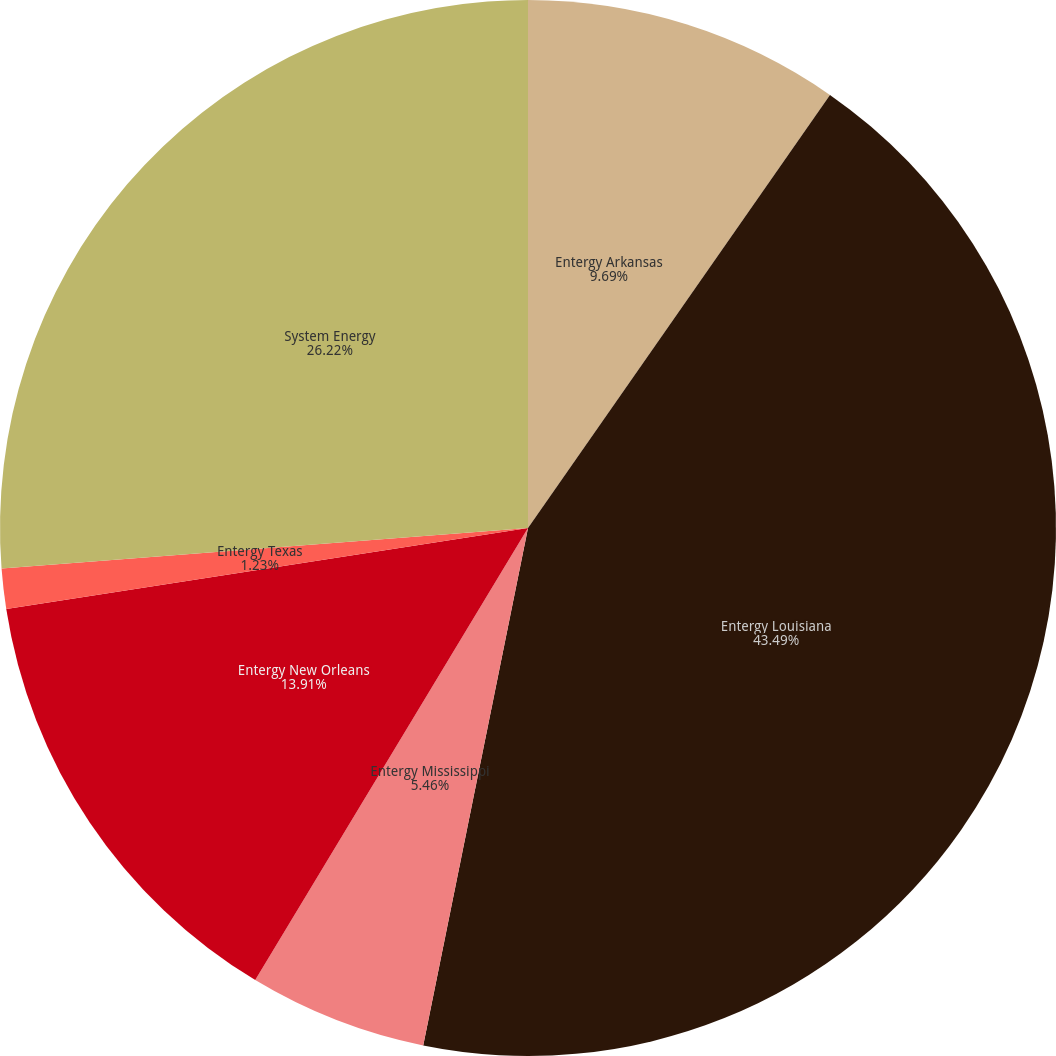Convert chart to OTSL. <chart><loc_0><loc_0><loc_500><loc_500><pie_chart><fcel>Entergy Arkansas<fcel>Entergy Louisiana<fcel>Entergy Mississippi<fcel>Entergy New Orleans<fcel>Entergy Texas<fcel>System Energy<nl><fcel>9.69%<fcel>43.49%<fcel>5.46%<fcel>13.91%<fcel>1.23%<fcel>26.22%<nl></chart> 